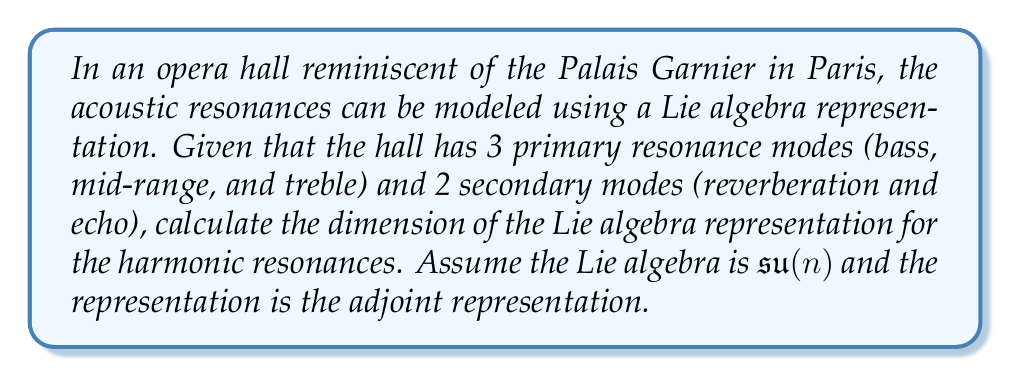Provide a solution to this math problem. To solve this problem, we need to follow these steps:

1) First, we need to determine the value of $n$ for our $\mathfrak{su}(n)$ Lie algebra. The total number of modes (primary and secondary) gives us this value:

   $n = 3 \text{ (primary)} + 2 \text{ (secondary)} = 5$

   So, we are working with $\mathfrak{su}(5)$.

2) For the adjoint representation of $\mathfrak{su}(n)$, the dimension is given by the formula:

   $\dim(\text{adj}(\mathfrak{su}(n))) = n^2 - 1$

3) Substituting $n = 5$ into this formula:

   $\dim(\text{adj}(\mathfrak{su}(5))) = 5^2 - 1 = 25 - 1 = 24$

Therefore, the dimension of the Lie algebra representation for the harmonic resonances in this opera hall is 24.

This means that there are 24 independent parameters or generators needed to fully describe the harmonic resonances in the hall, each corresponding to a possible transformation in the acoustic space of the opera hall.
Answer: The dimension of the Lie algebra representation for the harmonic resonances is 24. 